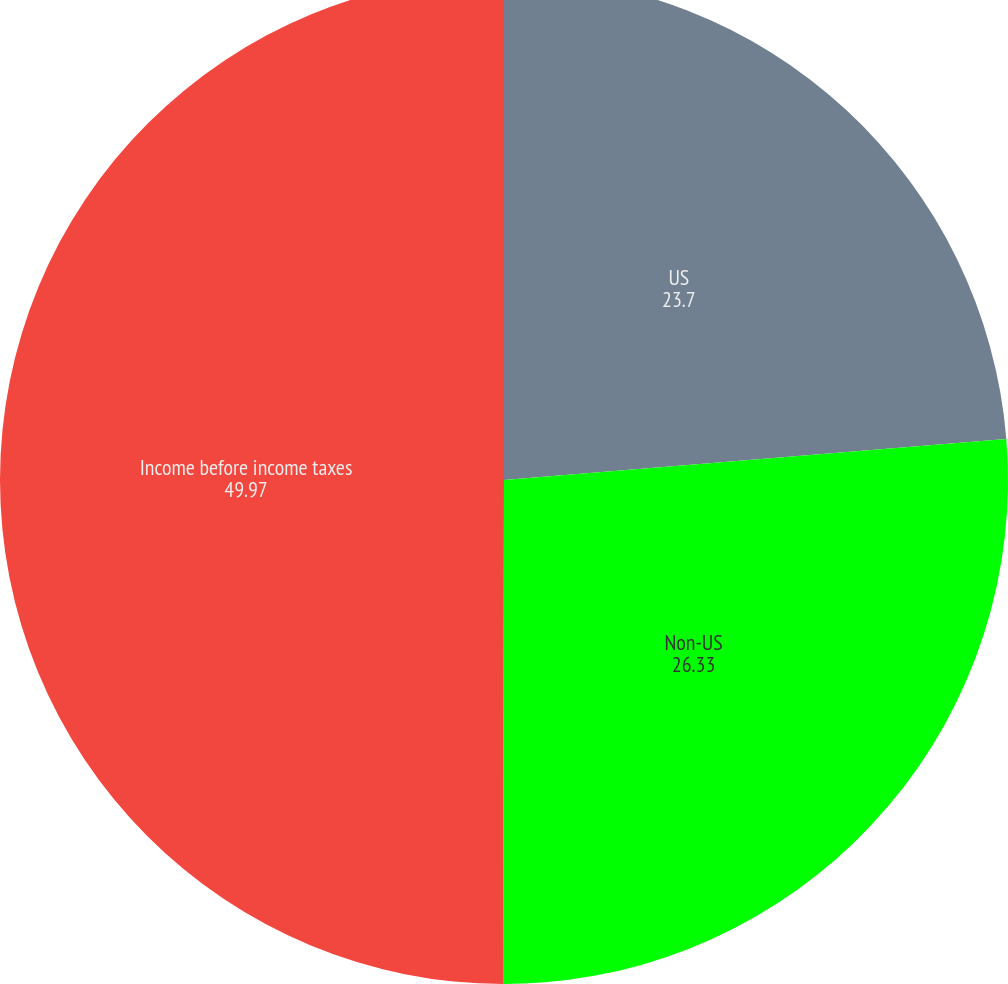Convert chart. <chart><loc_0><loc_0><loc_500><loc_500><pie_chart><fcel>US<fcel>Non-US<fcel>Income before income taxes<nl><fcel>23.7%<fcel>26.33%<fcel>49.97%<nl></chart> 